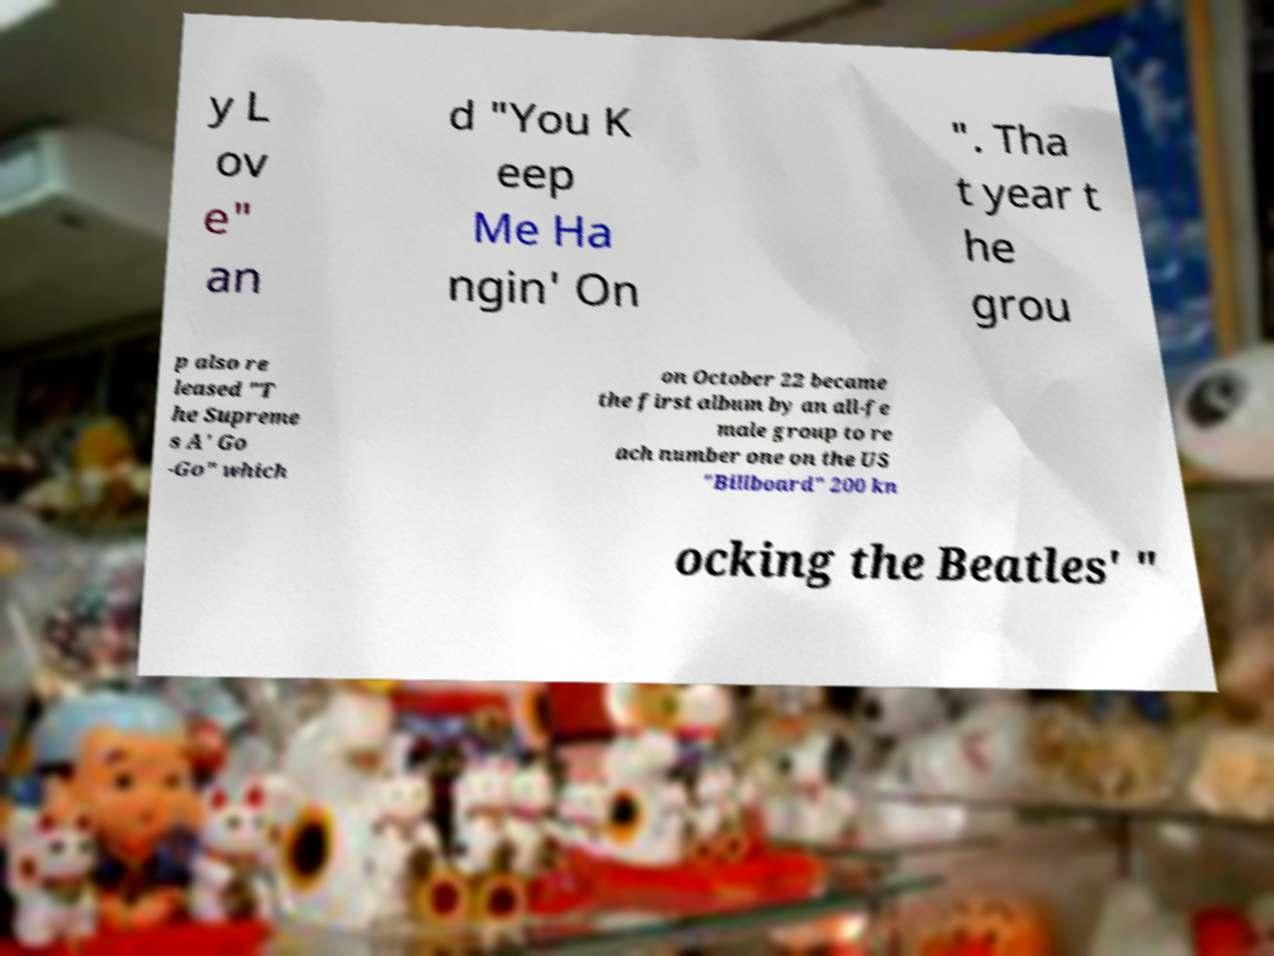What messages or text are displayed in this image? I need them in a readable, typed format. y L ov e" an d "You K eep Me Ha ngin' On ". Tha t year t he grou p also re leased "T he Supreme s A' Go -Go" which on October 22 became the first album by an all-fe male group to re ach number one on the US "Billboard" 200 kn ocking the Beatles' " 